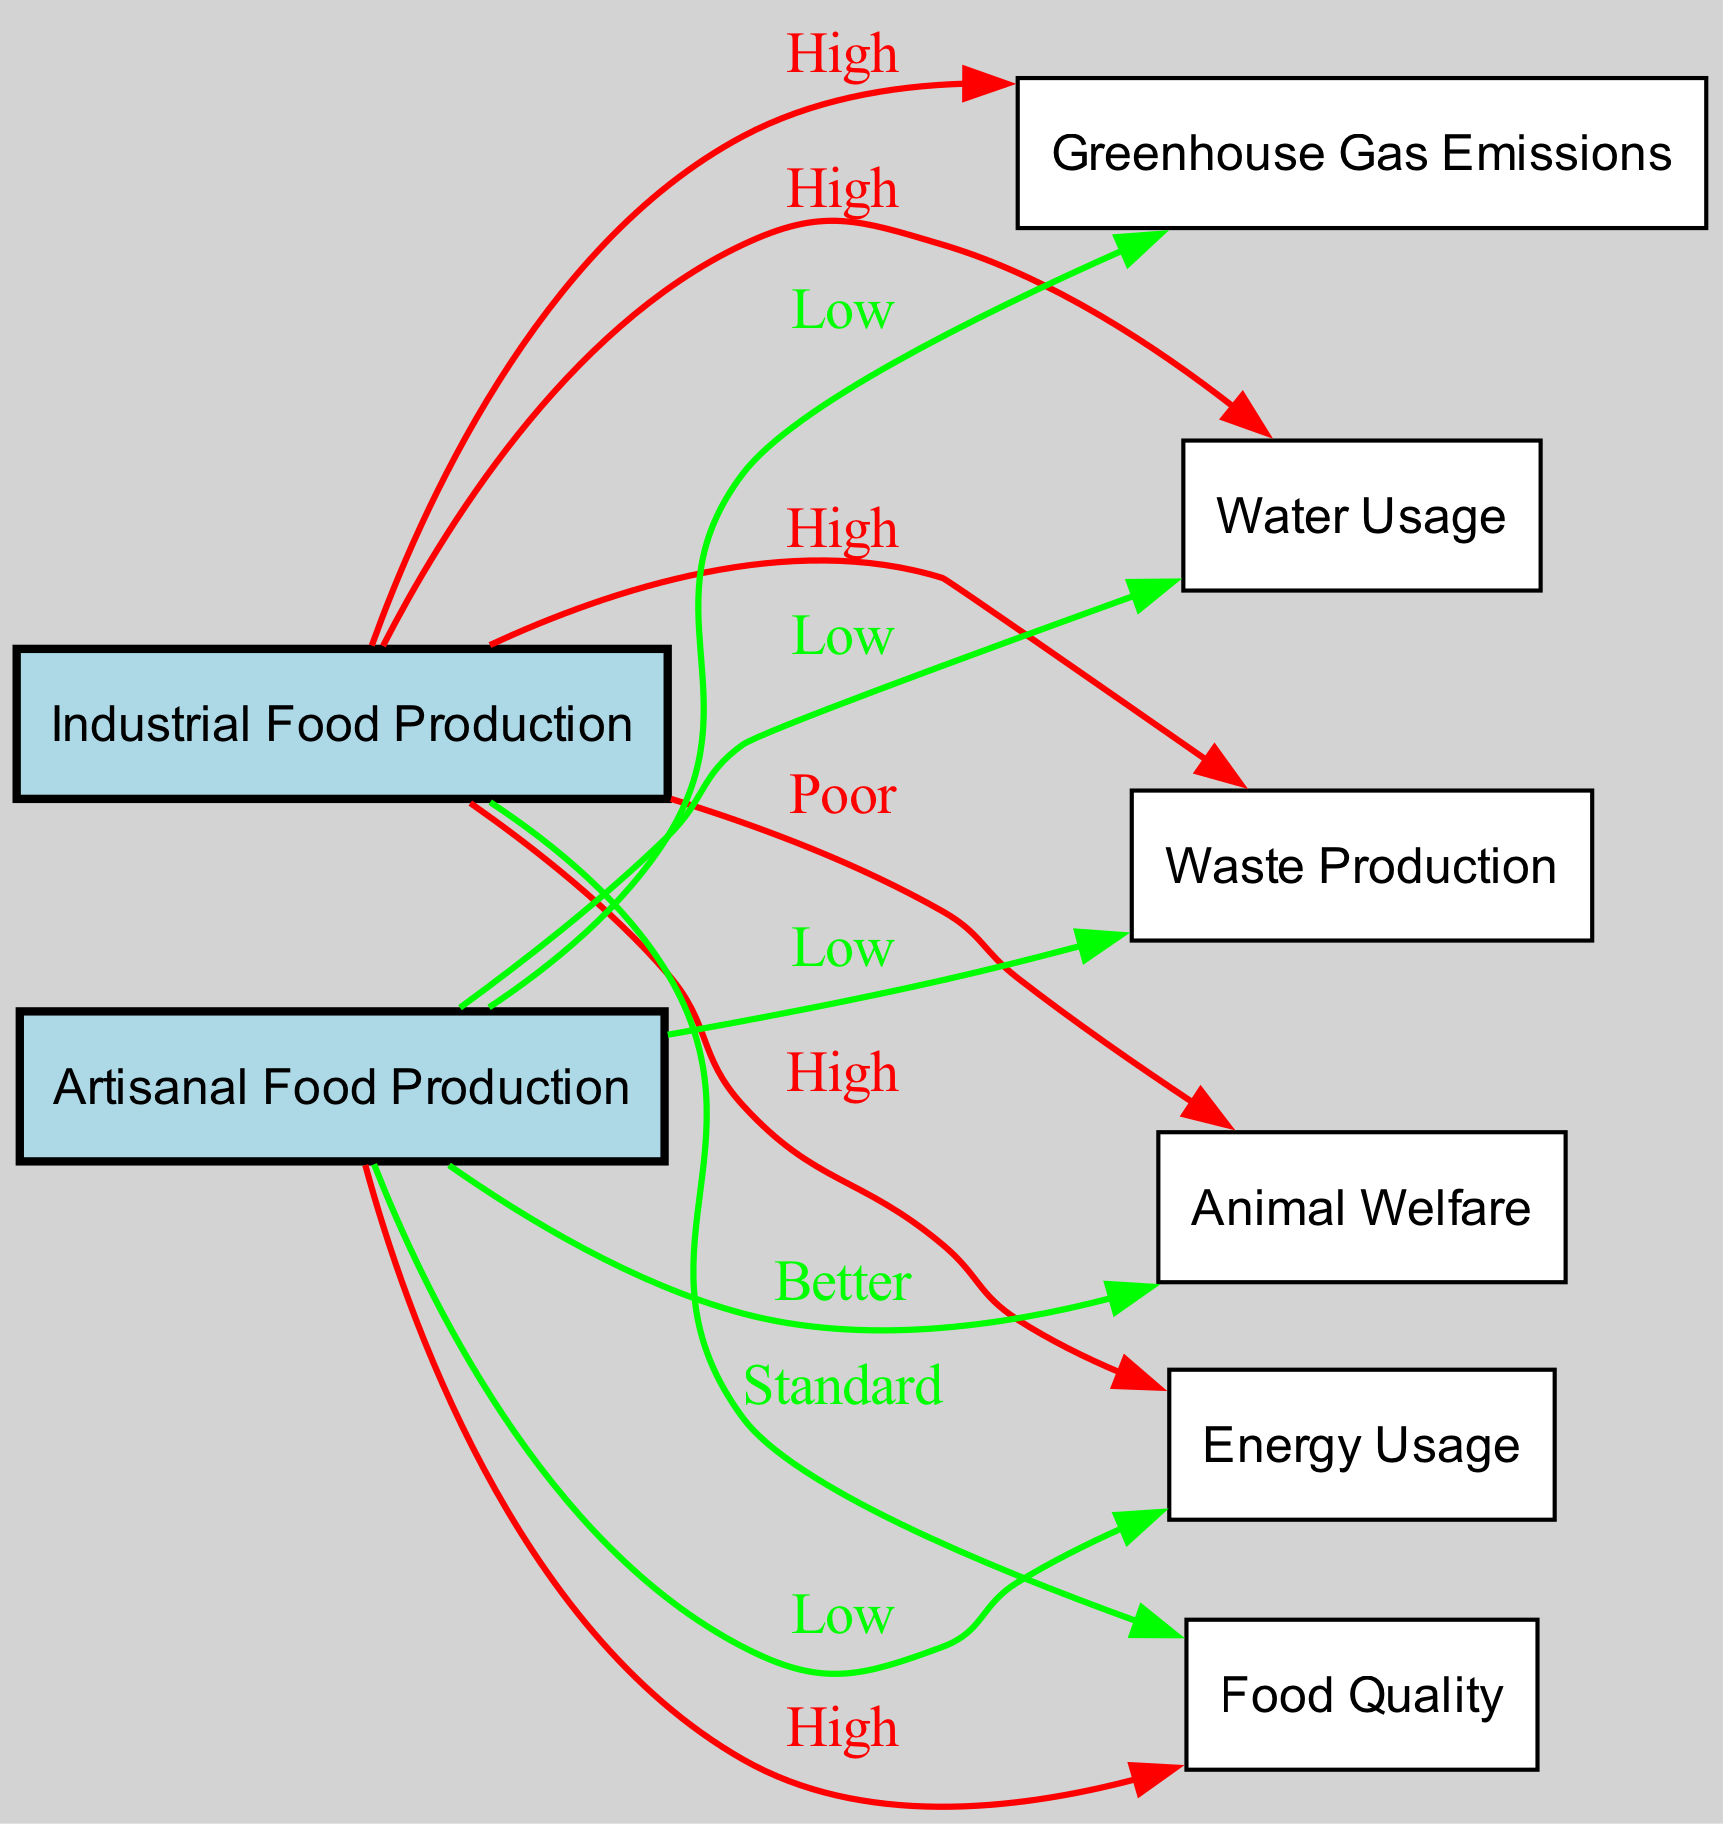What is the relationship between Industrial Food Production and Greenhouse Gas Emissions? The diagram indicates that the connection from Industrial Food Production to Greenhouse Gas Emissions is labeled "High," showing a significant impact on emissions.
Answer: High How many nodes are present in the diagram? Counting both the primary categories (Industrial Food Production and Artisanal Food Production) and their related factors (Greenhouse Gas Emissions, Energy Usage, Water Usage, Waste Production, Animal Welfare, Quality), there are a total of 8 nodes in the diagram.
Answer: 8 What is the level of Animal Welfare associated with Artisanal Food Production? The edge from Artisanal Food Production to Animal Welfare is labeled "Better," indicating a more ethical approach in food production that respects animal welfare.
Answer: Better Which food production method has lower Water Usage? The diagram shows a comparison between Industrial and Artisanal Food Production. The edge leading from Artisanal Food Production to Water Usage is labeled "Low," indicating that it uses less water compared to Industrial Food Production.
Answer: Artisanal Explain the connection between Energy Usage and both food production methods. The diagram has two edges going out of the "Energy Usage" category; one for Industrial, which is labeled "High," and another for Artisanal, labeled "Low." This indicates that Industrial Food Production consumes significantly more energy than Artisanal Food Production.
Answer: Industrial: High, Artisanal: Low Is the Food Quality higher in Artisanal or Industrial Food Production? The diagram indicates that the edge from Artisanal Food Production to Quality is labeled "High," whereas the edge from Industrial Food Production is labeled "Standard." This shows that Artisanal Food Production typically results in higher quality food.
Answer: Artisanal How does Waste Production compare between the two food production methods? The edge from Industrial Food Production to Waste Production is labeled "High" while the edge from Artisanal Food Production to Waste Production is labeled "Low." This comparison indicates that Industrial production generates more waste than Artisanal production.
Answer: High, Low What is the level of Greenhouse Gas Emissions in Artisanal Food Production? The connection between Artisanal Food Production and Greenhouse Gas Emissions is labeled "Low," indicating that this method has a smaller environmental impact in terms of these emissions compared to Industrial production.
Answer: Low 